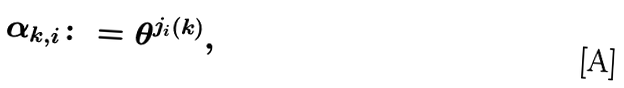<formula> <loc_0><loc_0><loc_500><loc_500>{ } \alpha _ { k , i } \colon = \theta ^ { j _ { i } ( k ) } ,</formula> 